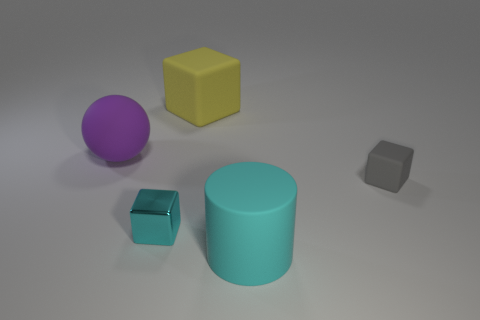Is the shape of the tiny cyan shiny thing the same as the small object to the right of the large yellow block?
Your answer should be very brief. Yes. The large matte thing to the right of the thing that is behind the large object to the left of the metal cube is what shape?
Provide a succinct answer. Cylinder. What number of other objects are there of the same material as the cylinder?
Provide a short and direct response. 3. How many objects are rubber blocks behind the gray cube or tiny cyan metallic things?
Provide a succinct answer. 2. What shape is the large rubber thing in front of the small thing that is right of the big cyan rubber thing?
Your answer should be very brief. Cylinder. Does the cyan object that is behind the large cylinder have the same shape as the small gray rubber object?
Make the answer very short. Yes. What is the color of the small block that is on the right side of the small cyan shiny cube?
Ensure brevity in your answer.  Gray. What number of balls are either large red metallic objects or big objects?
Your answer should be compact. 1. What size is the rubber cube in front of the rubber cube behind the purple ball?
Ensure brevity in your answer.  Small. There is a metallic block; is its color the same as the big object that is in front of the purple sphere?
Ensure brevity in your answer.  Yes. 